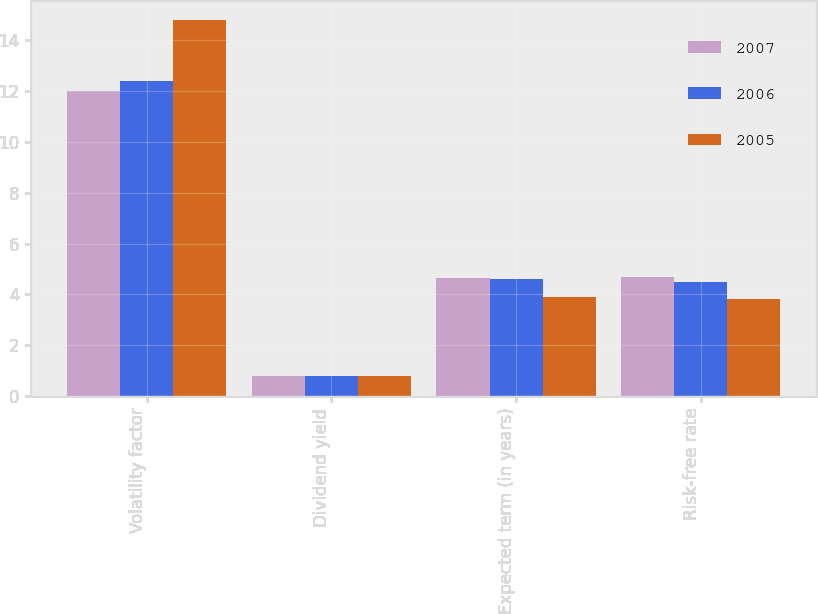<chart> <loc_0><loc_0><loc_500><loc_500><stacked_bar_chart><ecel><fcel>Volatility factor<fcel>Dividend yield<fcel>Expected term (in years)<fcel>Risk-free rate<nl><fcel>2007<fcel>12<fcel>0.8<fcel>4.64<fcel>4.7<nl><fcel>2006<fcel>12.4<fcel>0.8<fcel>4.61<fcel>4.5<nl><fcel>2005<fcel>14.8<fcel>0.8<fcel>3.9<fcel>3.8<nl></chart> 